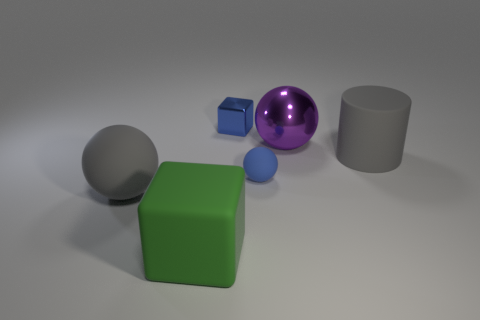Add 3 large matte spheres. How many objects exist? 9 Subtract all cubes. How many objects are left? 4 Subtract all blocks. Subtract all big green cubes. How many objects are left? 3 Add 2 metallic objects. How many metallic objects are left? 4 Add 2 small green rubber objects. How many small green rubber objects exist? 2 Subtract 0 cyan balls. How many objects are left? 6 